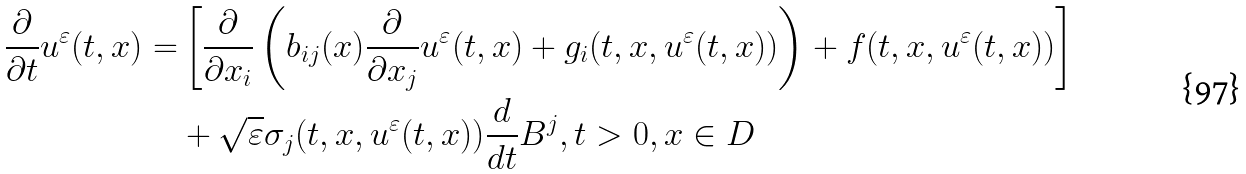<formula> <loc_0><loc_0><loc_500><loc_500>\frac { \partial } { \partial t } u ^ { \varepsilon } ( t , x ) = & \left [ \frac { \partial } { \partial x _ { i } } \left ( b _ { i j } ( x ) \frac { \partial } { \partial x _ { j } } u ^ { \varepsilon } ( t , x ) + g _ { i } ( t , x , u ^ { \varepsilon } ( t , x ) ) \right ) + f ( t , x , u ^ { \varepsilon } ( t , x ) ) \right ] \\ & + \sqrt { \varepsilon } { \sigma } _ { j } ( t , x , u ^ { \varepsilon } ( t , x ) ) \frac { d } { d t } B ^ { j } , t > 0 , x \in D</formula> 